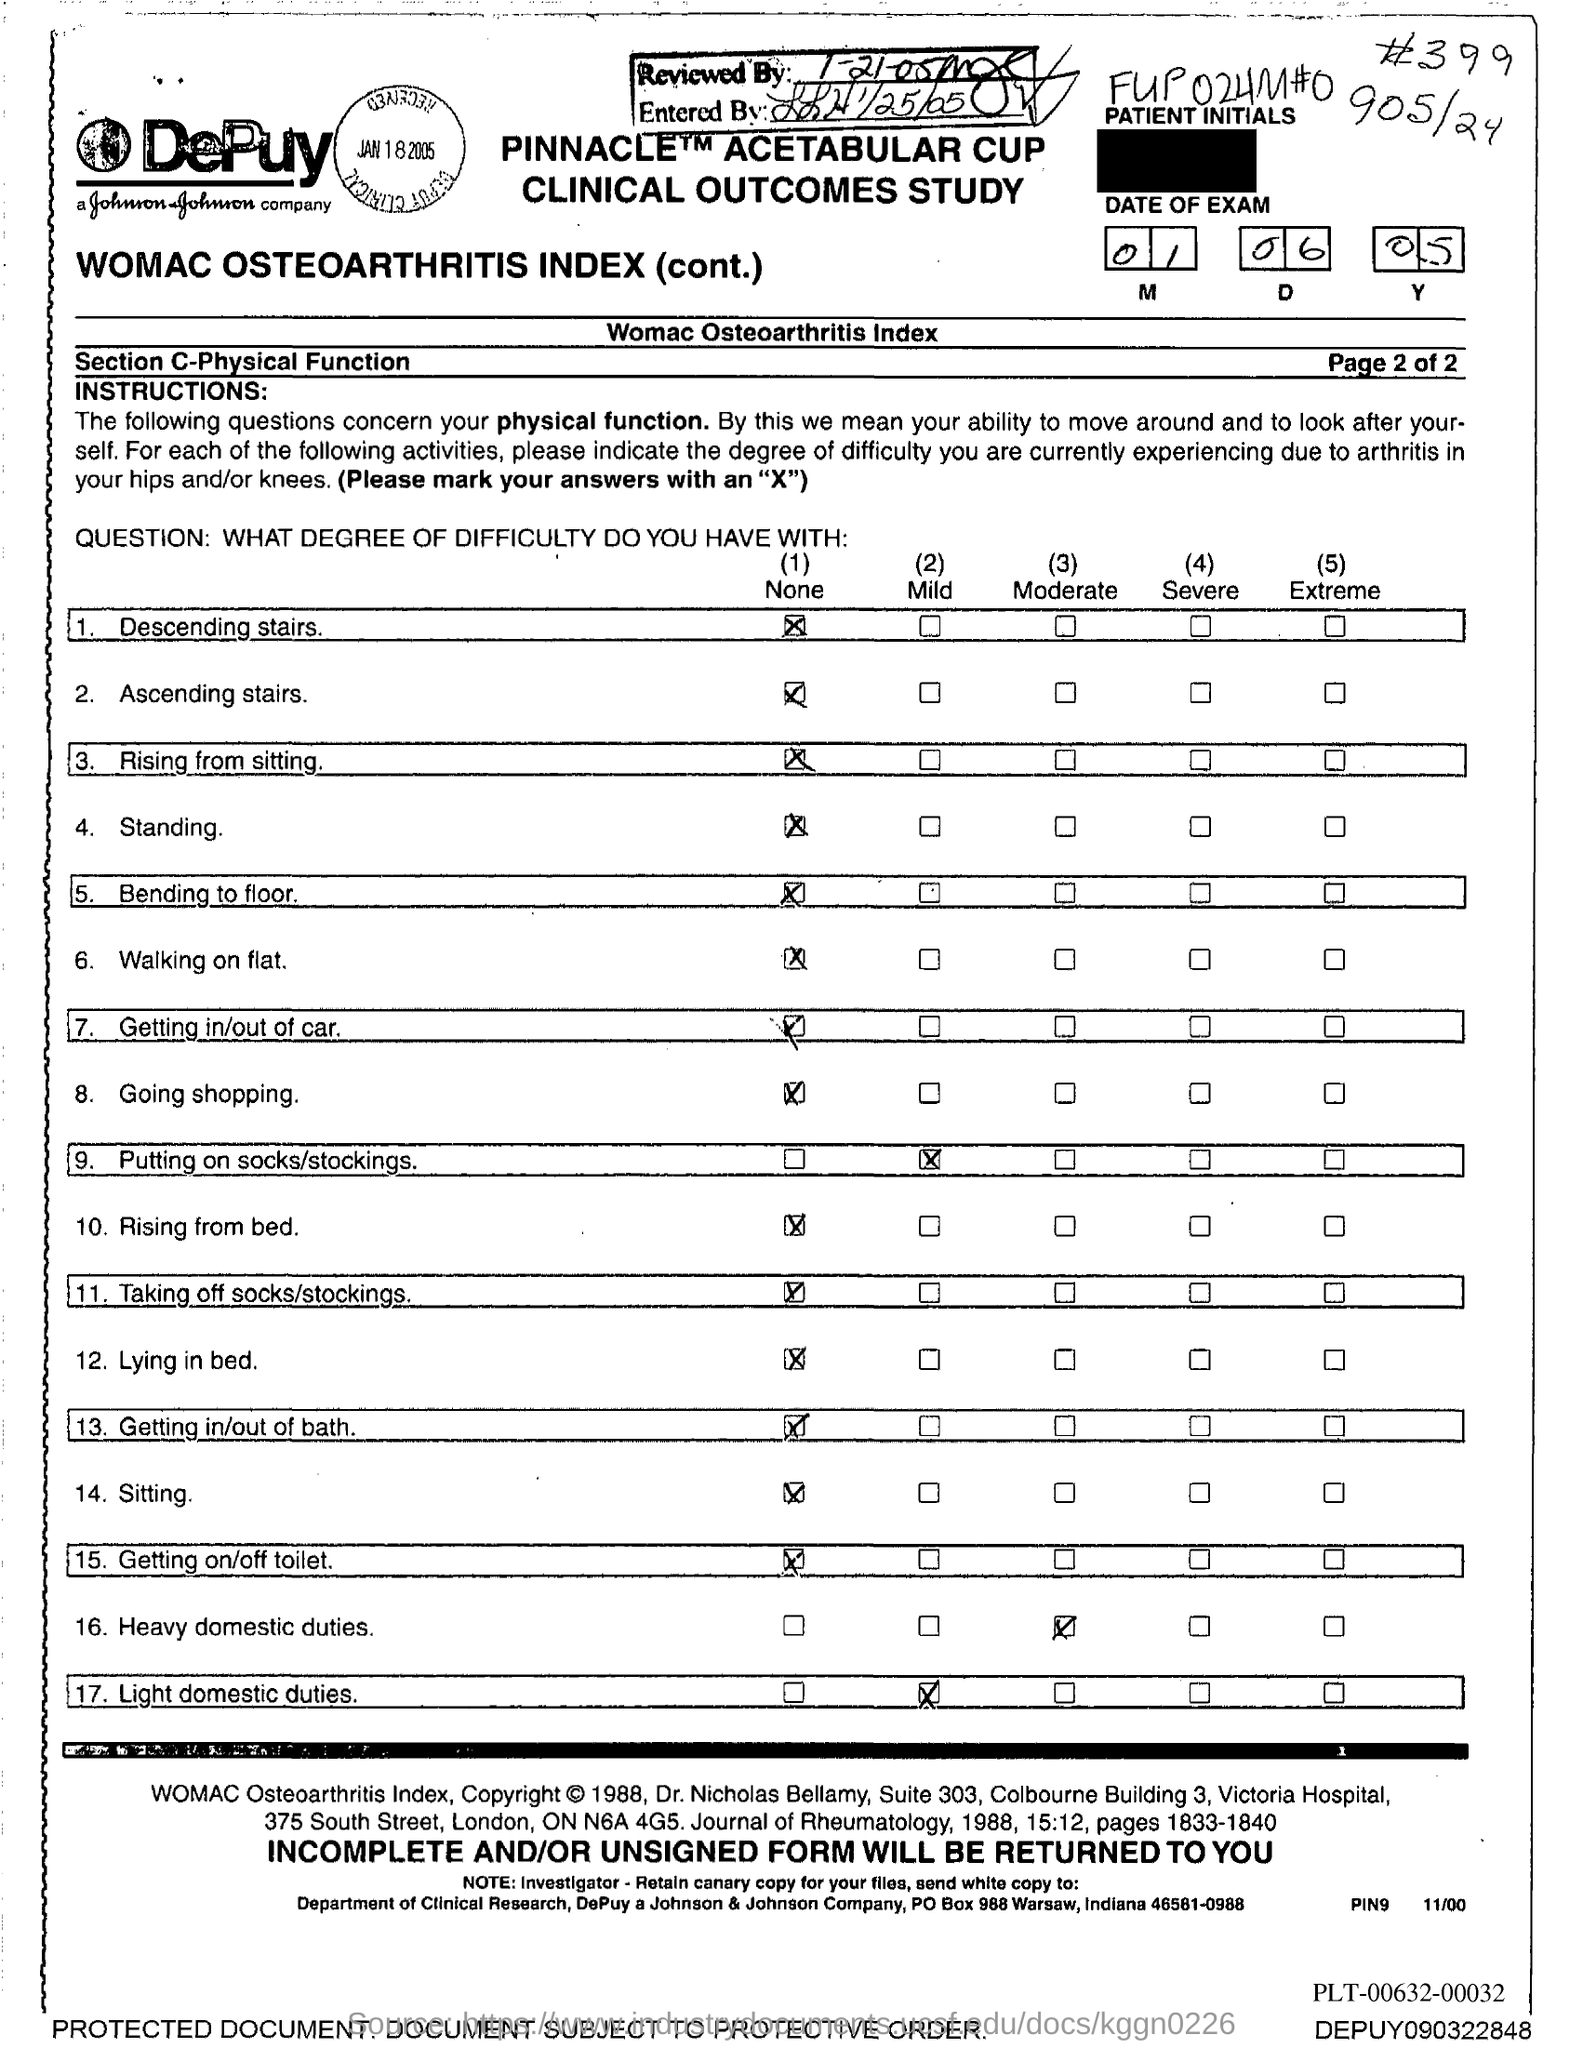Give some essential details in this illustration. The reviewed date mentioned in the document is 1-21-05. The entered date mentioned in the document is January 25, 2005. 